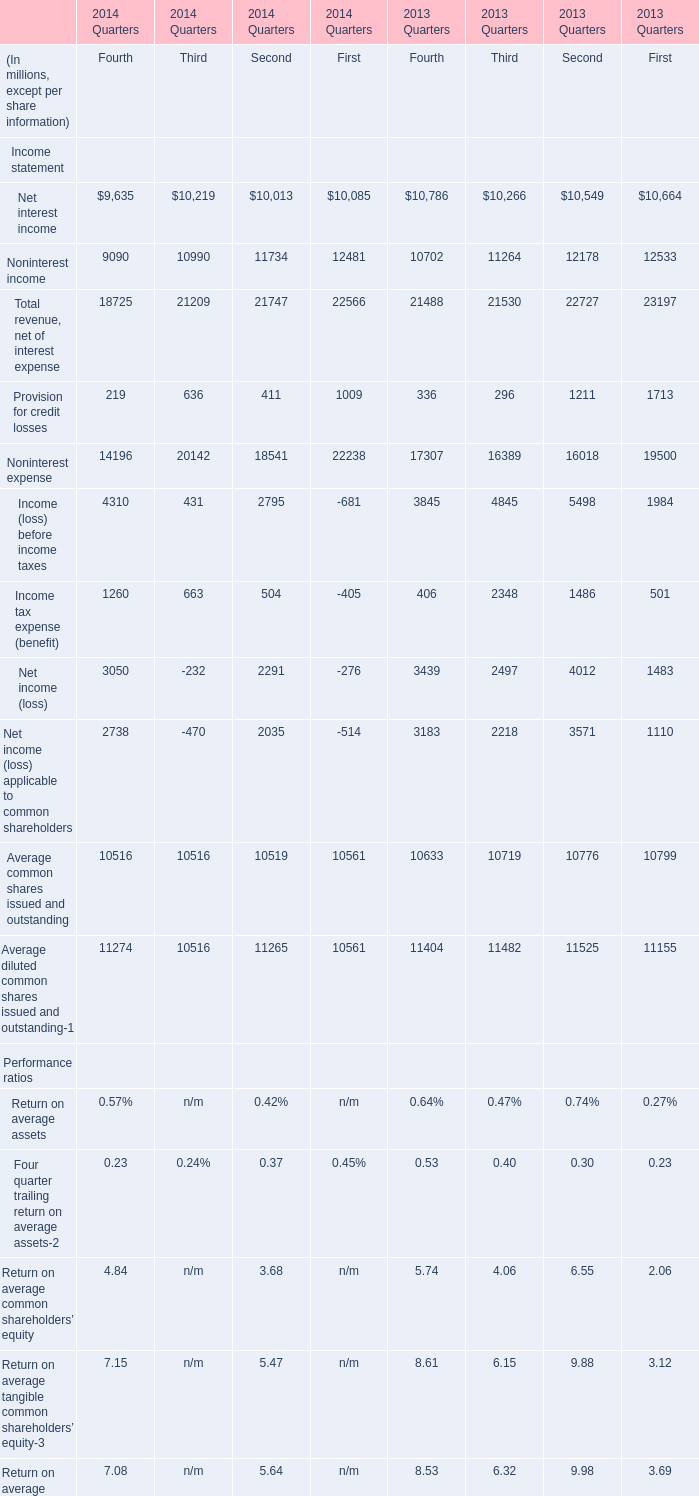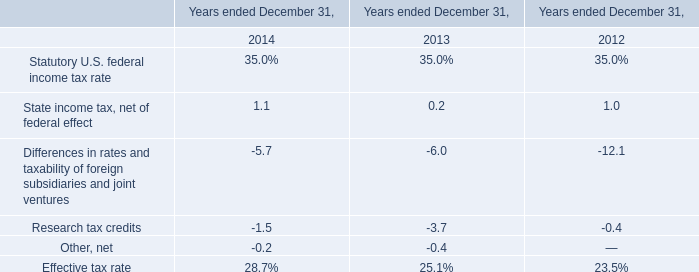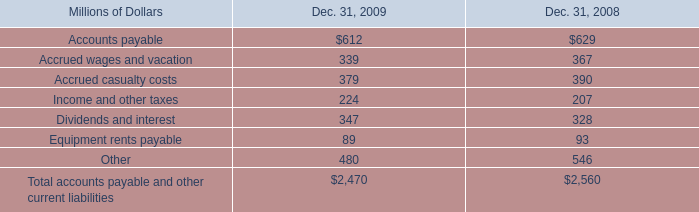what was the percentage increase in short term debt for amounts distributed to shareholders and debt holders during 2009? 
Computations: ((347 - 328) / 328)
Answer: 0.05793. 